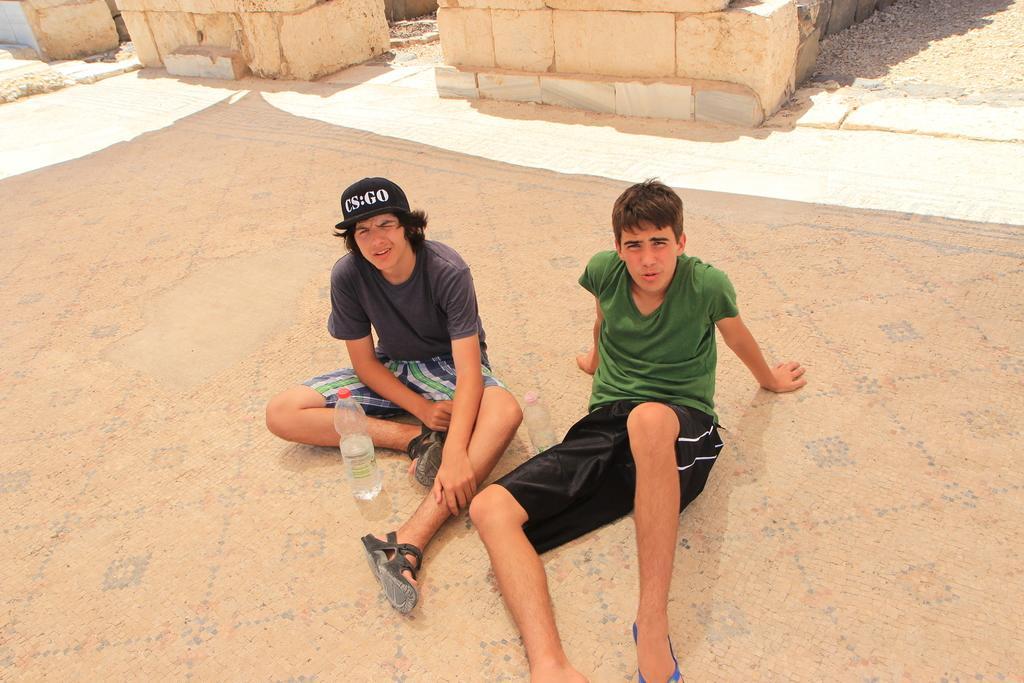How would you summarize this image in a sentence or two? In this picture there are two men sitting on the surface and we can see bottles. In the background of the image we can see walls. 